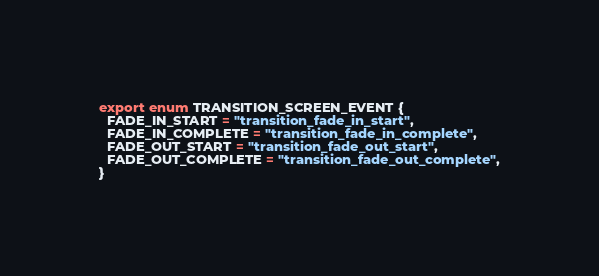Convert code to text. <code><loc_0><loc_0><loc_500><loc_500><_TypeScript_>export enum TRANSITION_SCREEN_EVENT {
  FADE_IN_START = "transition_fade_in_start",
  FADE_IN_COMPLETE = "transition_fade_in_complete",
  FADE_OUT_START = "transition_fade_out_start",
  FADE_OUT_COMPLETE = "transition_fade_out_complete",
}
</code> 